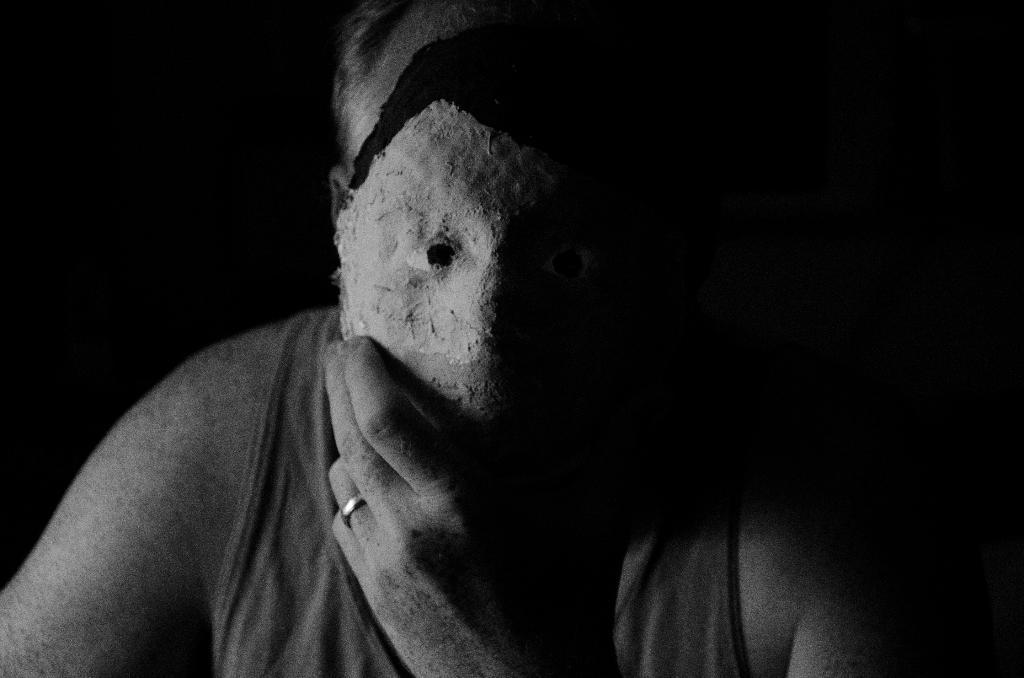Please provide a concise description of this image. In this picture there is a person holding a mask in his hand and placed it in front of his face. 